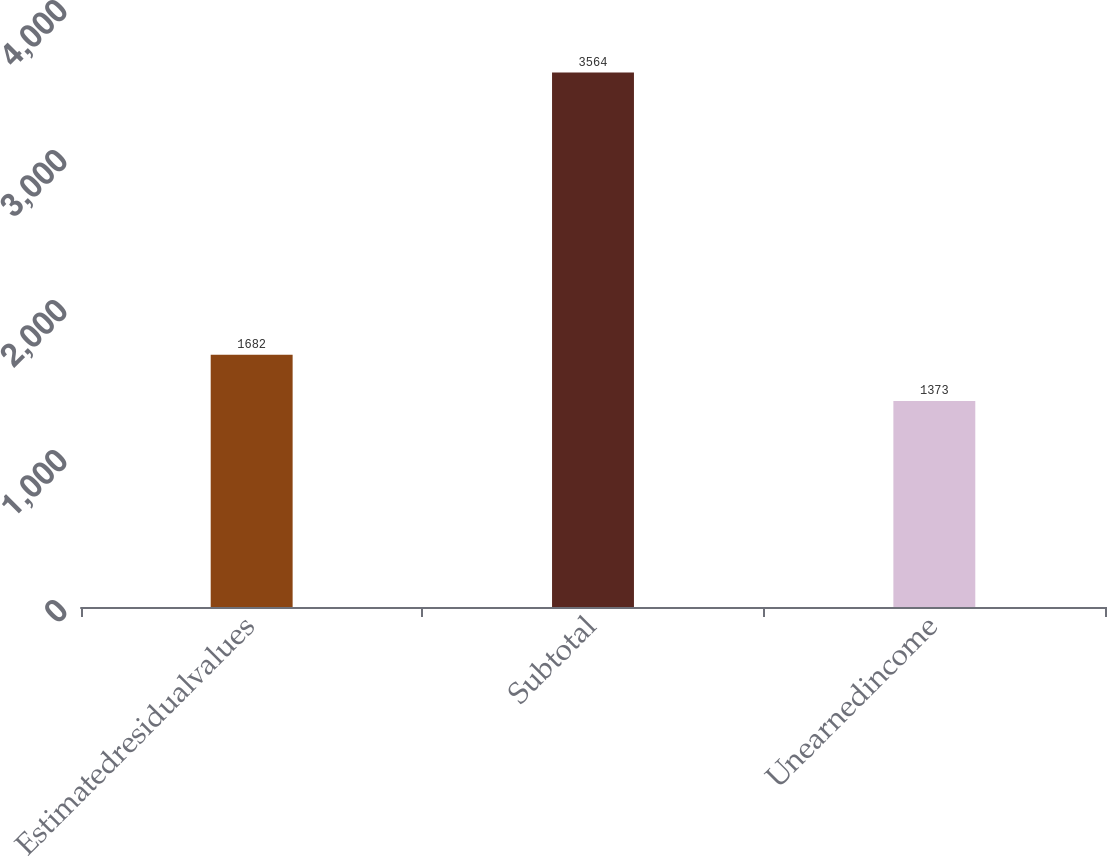Convert chart to OTSL. <chart><loc_0><loc_0><loc_500><loc_500><bar_chart><fcel>Estimatedresidualvalues<fcel>Subtotal<fcel>Unearnedincome<nl><fcel>1682<fcel>3564<fcel>1373<nl></chart> 